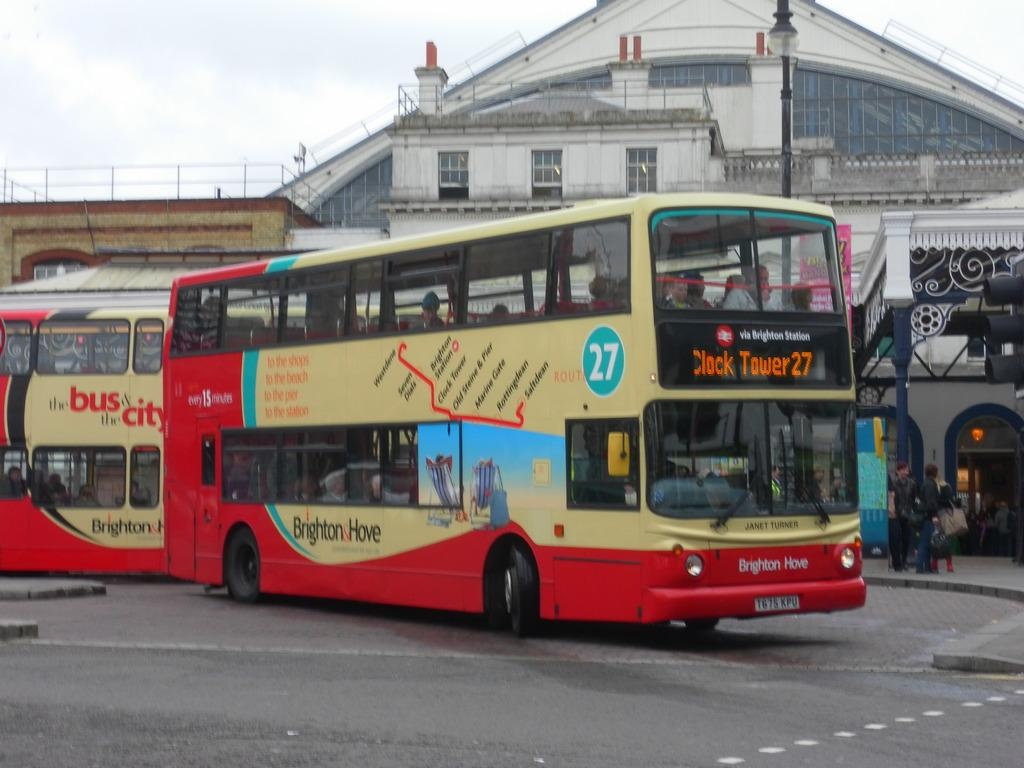<image>
Create a compact narrative representing the image presented. A bus with the number 27 written on the side 